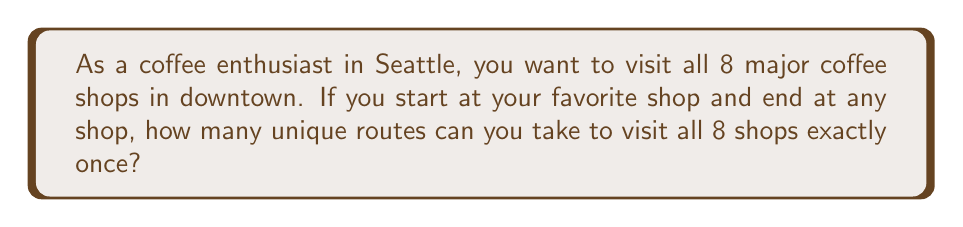Could you help me with this problem? Let's approach this step-by-step:

1) This problem is a variation of the Traveling Salesman Problem, but we don't need to return to the starting point.

2) We start at a fixed point (our favorite shop), so we don't need to consider permutations of the starting point.

3) We can end at any of the 8 shops, including our starting point.

4) For the remaining 7 shops, we need to calculate the number of ways to arrange them in a sequence.

5) This is a straightforward permutation problem. The number of permutations of n distinct objects is given by $n!$.

6) In this case, we have 7 shops to arrange: $7! = 7 \times 6 \times 5 \times 4 \times 3 \times 2 \times 1 = 5040$

7) Therefore, the total number of unique routes is 5040.

This can be expressed mathematically as:

$$ \text{Number of routes} = (n-1)! $$

Where $n$ is the total number of coffee shops (8 in this case).

$$ \text{Number of routes} = (8-1)! = 7! = 5040 $$
Answer: 5040 